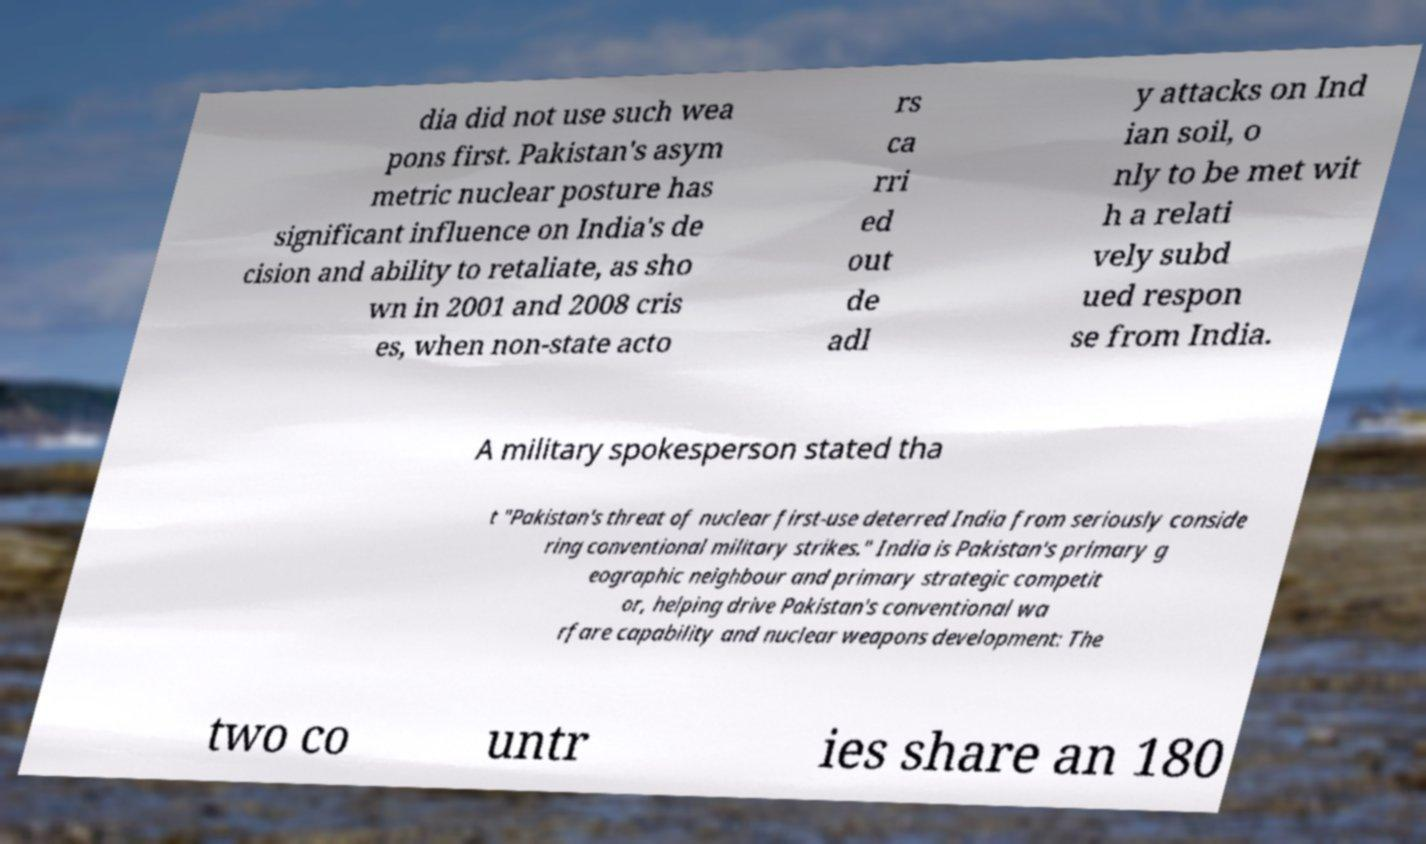Please read and relay the text visible in this image. What does it say? dia did not use such wea pons first. Pakistan's asym metric nuclear posture has significant influence on India's de cision and ability to retaliate, as sho wn in 2001 and 2008 cris es, when non-state acto rs ca rri ed out de adl y attacks on Ind ian soil, o nly to be met wit h a relati vely subd ued respon se from India. A military spokesperson stated tha t "Pakistan's threat of nuclear first-use deterred India from seriously conside ring conventional military strikes." India is Pakistan's primary g eographic neighbour and primary strategic competit or, helping drive Pakistan's conventional wa rfare capability and nuclear weapons development: The two co untr ies share an 180 